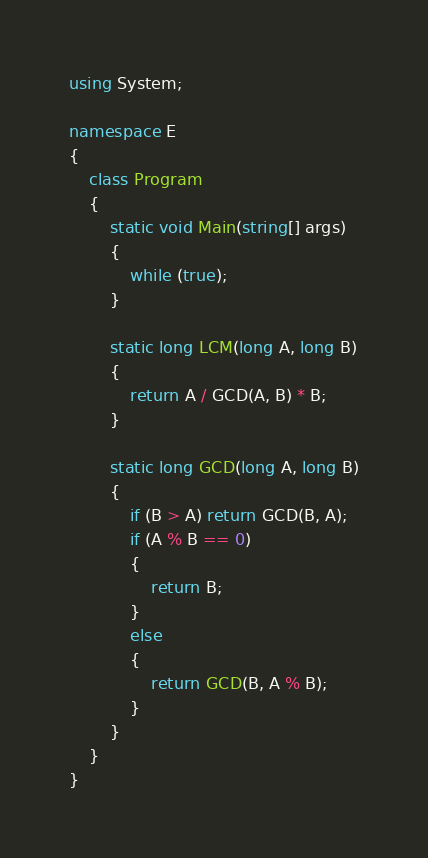<code> <loc_0><loc_0><loc_500><loc_500><_C#_>using System;

namespace E
{
    class Program
    {
        static void Main(string[] args)
        {
			while (true);
        }

        static long LCM(long A, long B)
        {
            return A / GCD(A, B) * B;
        }

        static long GCD(long A, long B)
        {
            if (B > A) return GCD(B, A);
            if (A % B == 0)
            {
                return B;
            }
            else
            {
                return GCD(B, A % B);
            }
        }
    }
}
</code> 